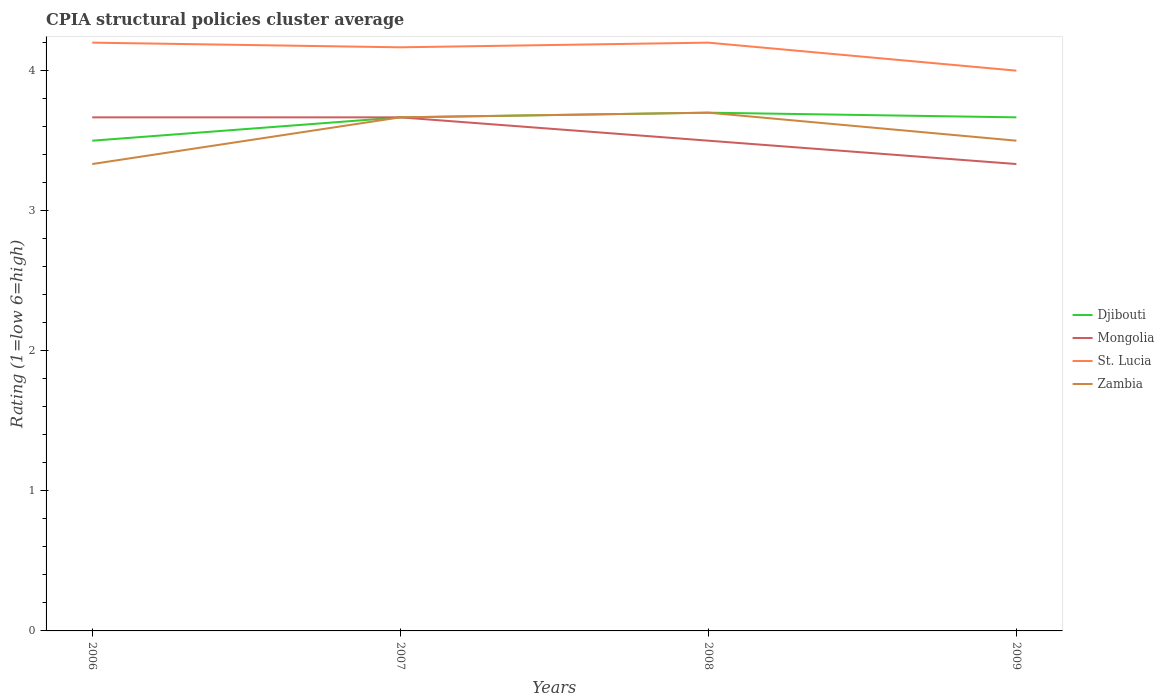How many different coloured lines are there?
Provide a succinct answer. 4. Does the line corresponding to Zambia intersect with the line corresponding to Mongolia?
Provide a short and direct response. Yes. Across all years, what is the maximum CPIA rating in Mongolia?
Provide a succinct answer. 3.33. In which year was the CPIA rating in Djibouti maximum?
Offer a very short reply. 2006. What is the total CPIA rating in Mongolia in the graph?
Offer a very short reply. 0.33. What is the difference between the highest and the second highest CPIA rating in Mongolia?
Offer a very short reply. 0.33. How many lines are there?
Your answer should be compact. 4. How many years are there in the graph?
Your response must be concise. 4. Are the values on the major ticks of Y-axis written in scientific E-notation?
Give a very brief answer. No. Does the graph contain any zero values?
Provide a short and direct response. No. Does the graph contain grids?
Offer a very short reply. No. Where does the legend appear in the graph?
Make the answer very short. Center right. How many legend labels are there?
Provide a succinct answer. 4. What is the title of the graph?
Ensure brevity in your answer.  CPIA structural policies cluster average. Does "Timor-Leste" appear as one of the legend labels in the graph?
Your answer should be very brief. No. What is the Rating (1=low 6=high) in Mongolia in 2006?
Your answer should be very brief. 3.67. What is the Rating (1=low 6=high) in Zambia in 2006?
Your answer should be compact. 3.33. What is the Rating (1=low 6=high) in Djibouti in 2007?
Offer a very short reply. 3.67. What is the Rating (1=low 6=high) of Mongolia in 2007?
Offer a terse response. 3.67. What is the Rating (1=low 6=high) of St. Lucia in 2007?
Your answer should be very brief. 4.17. What is the Rating (1=low 6=high) in Zambia in 2007?
Ensure brevity in your answer.  3.67. What is the Rating (1=low 6=high) of Djibouti in 2008?
Give a very brief answer. 3.7. What is the Rating (1=low 6=high) of St. Lucia in 2008?
Make the answer very short. 4.2. What is the Rating (1=low 6=high) in Zambia in 2008?
Provide a short and direct response. 3.7. What is the Rating (1=low 6=high) of Djibouti in 2009?
Give a very brief answer. 3.67. What is the Rating (1=low 6=high) in Mongolia in 2009?
Provide a short and direct response. 3.33. Across all years, what is the maximum Rating (1=low 6=high) in Mongolia?
Give a very brief answer. 3.67. Across all years, what is the minimum Rating (1=low 6=high) of Mongolia?
Give a very brief answer. 3.33. Across all years, what is the minimum Rating (1=low 6=high) in Zambia?
Your answer should be compact. 3.33. What is the total Rating (1=low 6=high) in Djibouti in the graph?
Provide a short and direct response. 14.53. What is the total Rating (1=low 6=high) of Mongolia in the graph?
Your response must be concise. 14.17. What is the total Rating (1=low 6=high) in St. Lucia in the graph?
Offer a terse response. 16.57. What is the difference between the Rating (1=low 6=high) in Djibouti in 2006 and that in 2007?
Provide a short and direct response. -0.17. What is the difference between the Rating (1=low 6=high) of Mongolia in 2006 and that in 2007?
Make the answer very short. 0. What is the difference between the Rating (1=low 6=high) in Zambia in 2006 and that in 2007?
Give a very brief answer. -0.33. What is the difference between the Rating (1=low 6=high) of Zambia in 2006 and that in 2008?
Keep it short and to the point. -0.37. What is the difference between the Rating (1=low 6=high) in St. Lucia in 2006 and that in 2009?
Provide a succinct answer. 0.2. What is the difference between the Rating (1=low 6=high) in Djibouti in 2007 and that in 2008?
Make the answer very short. -0.03. What is the difference between the Rating (1=low 6=high) in Mongolia in 2007 and that in 2008?
Provide a short and direct response. 0.17. What is the difference between the Rating (1=low 6=high) of St. Lucia in 2007 and that in 2008?
Keep it short and to the point. -0.03. What is the difference between the Rating (1=low 6=high) in Zambia in 2007 and that in 2008?
Your answer should be very brief. -0.03. What is the difference between the Rating (1=low 6=high) of Mongolia in 2007 and that in 2009?
Provide a short and direct response. 0.33. What is the difference between the Rating (1=low 6=high) in Zambia in 2008 and that in 2009?
Offer a terse response. 0.2. What is the difference between the Rating (1=low 6=high) in Djibouti in 2006 and the Rating (1=low 6=high) in Mongolia in 2007?
Ensure brevity in your answer.  -0.17. What is the difference between the Rating (1=low 6=high) in Djibouti in 2006 and the Rating (1=low 6=high) in Zambia in 2007?
Provide a succinct answer. -0.17. What is the difference between the Rating (1=low 6=high) in Mongolia in 2006 and the Rating (1=low 6=high) in St. Lucia in 2007?
Offer a terse response. -0.5. What is the difference between the Rating (1=low 6=high) in St. Lucia in 2006 and the Rating (1=low 6=high) in Zambia in 2007?
Ensure brevity in your answer.  0.53. What is the difference between the Rating (1=low 6=high) in Djibouti in 2006 and the Rating (1=low 6=high) in Mongolia in 2008?
Give a very brief answer. 0. What is the difference between the Rating (1=low 6=high) in Djibouti in 2006 and the Rating (1=low 6=high) in St. Lucia in 2008?
Make the answer very short. -0.7. What is the difference between the Rating (1=low 6=high) of Mongolia in 2006 and the Rating (1=low 6=high) of St. Lucia in 2008?
Provide a short and direct response. -0.53. What is the difference between the Rating (1=low 6=high) in Mongolia in 2006 and the Rating (1=low 6=high) in Zambia in 2008?
Your answer should be compact. -0.03. What is the difference between the Rating (1=low 6=high) in St. Lucia in 2006 and the Rating (1=low 6=high) in Zambia in 2008?
Offer a terse response. 0.5. What is the difference between the Rating (1=low 6=high) in Mongolia in 2006 and the Rating (1=low 6=high) in St. Lucia in 2009?
Provide a short and direct response. -0.33. What is the difference between the Rating (1=low 6=high) in Djibouti in 2007 and the Rating (1=low 6=high) in St. Lucia in 2008?
Give a very brief answer. -0.53. What is the difference between the Rating (1=low 6=high) of Djibouti in 2007 and the Rating (1=low 6=high) of Zambia in 2008?
Your response must be concise. -0.03. What is the difference between the Rating (1=low 6=high) of Mongolia in 2007 and the Rating (1=low 6=high) of St. Lucia in 2008?
Give a very brief answer. -0.53. What is the difference between the Rating (1=low 6=high) in Mongolia in 2007 and the Rating (1=low 6=high) in Zambia in 2008?
Provide a succinct answer. -0.03. What is the difference between the Rating (1=low 6=high) of St. Lucia in 2007 and the Rating (1=low 6=high) of Zambia in 2008?
Offer a very short reply. 0.47. What is the difference between the Rating (1=low 6=high) in Djibouti in 2007 and the Rating (1=low 6=high) in St. Lucia in 2009?
Your answer should be compact. -0.33. What is the difference between the Rating (1=low 6=high) in Djibouti in 2007 and the Rating (1=low 6=high) in Zambia in 2009?
Make the answer very short. 0.17. What is the difference between the Rating (1=low 6=high) in Mongolia in 2007 and the Rating (1=low 6=high) in St. Lucia in 2009?
Ensure brevity in your answer.  -0.33. What is the difference between the Rating (1=low 6=high) of Djibouti in 2008 and the Rating (1=low 6=high) of Mongolia in 2009?
Your response must be concise. 0.37. What is the difference between the Rating (1=low 6=high) of Djibouti in 2008 and the Rating (1=low 6=high) of St. Lucia in 2009?
Ensure brevity in your answer.  -0.3. What is the difference between the Rating (1=low 6=high) of Djibouti in 2008 and the Rating (1=low 6=high) of Zambia in 2009?
Your answer should be compact. 0.2. What is the difference between the Rating (1=low 6=high) of Mongolia in 2008 and the Rating (1=low 6=high) of St. Lucia in 2009?
Make the answer very short. -0.5. What is the average Rating (1=low 6=high) in Djibouti per year?
Give a very brief answer. 3.63. What is the average Rating (1=low 6=high) of Mongolia per year?
Keep it short and to the point. 3.54. What is the average Rating (1=low 6=high) of St. Lucia per year?
Your answer should be compact. 4.14. What is the average Rating (1=low 6=high) of Zambia per year?
Provide a short and direct response. 3.55. In the year 2006, what is the difference between the Rating (1=low 6=high) in Djibouti and Rating (1=low 6=high) in Mongolia?
Offer a terse response. -0.17. In the year 2006, what is the difference between the Rating (1=low 6=high) in Djibouti and Rating (1=low 6=high) in Zambia?
Your answer should be very brief. 0.17. In the year 2006, what is the difference between the Rating (1=low 6=high) in Mongolia and Rating (1=low 6=high) in St. Lucia?
Ensure brevity in your answer.  -0.53. In the year 2006, what is the difference between the Rating (1=low 6=high) in Mongolia and Rating (1=low 6=high) in Zambia?
Ensure brevity in your answer.  0.33. In the year 2006, what is the difference between the Rating (1=low 6=high) in St. Lucia and Rating (1=low 6=high) in Zambia?
Provide a short and direct response. 0.87. In the year 2007, what is the difference between the Rating (1=low 6=high) of Djibouti and Rating (1=low 6=high) of Mongolia?
Your response must be concise. 0. In the year 2007, what is the difference between the Rating (1=low 6=high) of Djibouti and Rating (1=low 6=high) of St. Lucia?
Provide a succinct answer. -0.5. In the year 2007, what is the difference between the Rating (1=low 6=high) of Mongolia and Rating (1=low 6=high) of Zambia?
Offer a terse response. 0. In the year 2008, what is the difference between the Rating (1=low 6=high) in Djibouti and Rating (1=low 6=high) in Mongolia?
Keep it short and to the point. 0.2. In the year 2008, what is the difference between the Rating (1=low 6=high) in Djibouti and Rating (1=low 6=high) in St. Lucia?
Your response must be concise. -0.5. In the year 2008, what is the difference between the Rating (1=low 6=high) of Djibouti and Rating (1=low 6=high) of Zambia?
Offer a terse response. 0. In the year 2008, what is the difference between the Rating (1=low 6=high) in Mongolia and Rating (1=low 6=high) in Zambia?
Your answer should be very brief. -0.2. In the year 2009, what is the difference between the Rating (1=low 6=high) of Djibouti and Rating (1=low 6=high) of Mongolia?
Ensure brevity in your answer.  0.33. In the year 2009, what is the difference between the Rating (1=low 6=high) in St. Lucia and Rating (1=low 6=high) in Zambia?
Ensure brevity in your answer.  0.5. What is the ratio of the Rating (1=low 6=high) in Djibouti in 2006 to that in 2007?
Give a very brief answer. 0.95. What is the ratio of the Rating (1=low 6=high) in Mongolia in 2006 to that in 2007?
Offer a terse response. 1. What is the ratio of the Rating (1=low 6=high) in Zambia in 2006 to that in 2007?
Your answer should be very brief. 0.91. What is the ratio of the Rating (1=low 6=high) of Djibouti in 2006 to that in 2008?
Your answer should be very brief. 0.95. What is the ratio of the Rating (1=low 6=high) in Mongolia in 2006 to that in 2008?
Provide a short and direct response. 1.05. What is the ratio of the Rating (1=low 6=high) in St. Lucia in 2006 to that in 2008?
Your answer should be compact. 1. What is the ratio of the Rating (1=low 6=high) in Zambia in 2006 to that in 2008?
Offer a very short reply. 0.9. What is the ratio of the Rating (1=low 6=high) of Djibouti in 2006 to that in 2009?
Offer a terse response. 0.95. What is the ratio of the Rating (1=low 6=high) of Mongolia in 2006 to that in 2009?
Offer a terse response. 1.1. What is the ratio of the Rating (1=low 6=high) of St. Lucia in 2006 to that in 2009?
Your response must be concise. 1.05. What is the ratio of the Rating (1=low 6=high) of Mongolia in 2007 to that in 2008?
Offer a terse response. 1.05. What is the ratio of the Rating (1=low 6=high) of St. Lucia in 2007 to that in 2008?
Your response must be concise. 0.99. What is the ratio of the Rating (1=low 6=high) in Zambia in 2007 to that in 2008?
Your answer should be compact. 0.99. What is the ratio of the Rating (1=low 6=high) of Mongolia in 2007 to that in 2009?
Offer a very short reply. 1.1. What is the ratio of the Rating (1=low 6=high) of St. Lucia in 2007 to that in 2009?
Make the answer very short. 1.04. What is the ratio of the Rating (1=low 6=high) of Zambia in 2007 to that in 2009?
Ensure brevity in your answer.  1.05. What is the ratio of the Rating (1=low 6=high) in Djibouti in 2008 to that in 2009?
Offer a very short reply. 1.01. What is the ratio of the Rating (1=low 6=high) of Mongolia in 2008 to that in 2009?
Give a very brief answer. 1.05. What is the ratio of the Rating (1=low 6=high) in Zambia in 2008 to that in 2009?
Offer a terse response. 1.06. What is the difference between the highest and the second highest Rating (1=low 6=high) in Djibouti?
Give a very brief answer. 0.03. What is the difference between the highest and the second highest Rating (1=low 6=high) in St. Lucia?
Keep it short and to the point. 0. What is the difference between the highest and the lowest Rating (1=low 6=high) of Zambia?
Offer a very short reply. 0.37. 